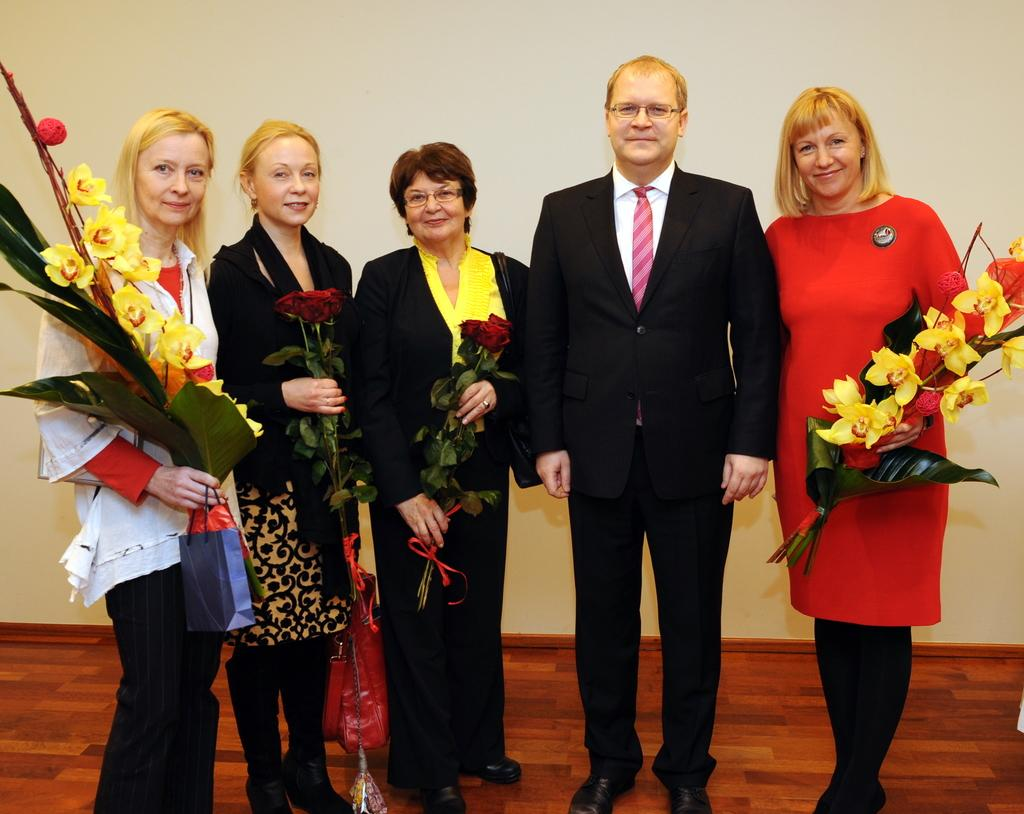What are the people in the image doing? The people in the image are standing. What are some of the people holding in the image? Some people are holding flowers or bouquets in the image. What can be seen beneath the people's feet in the image? The ground is visible in the image. What is present in the background of the image? There is a wall in the image. What type of shoe is visible in the image? There is no shoe present in the image. Is there any smoke visible in the image? There is no smoke present in the image. 